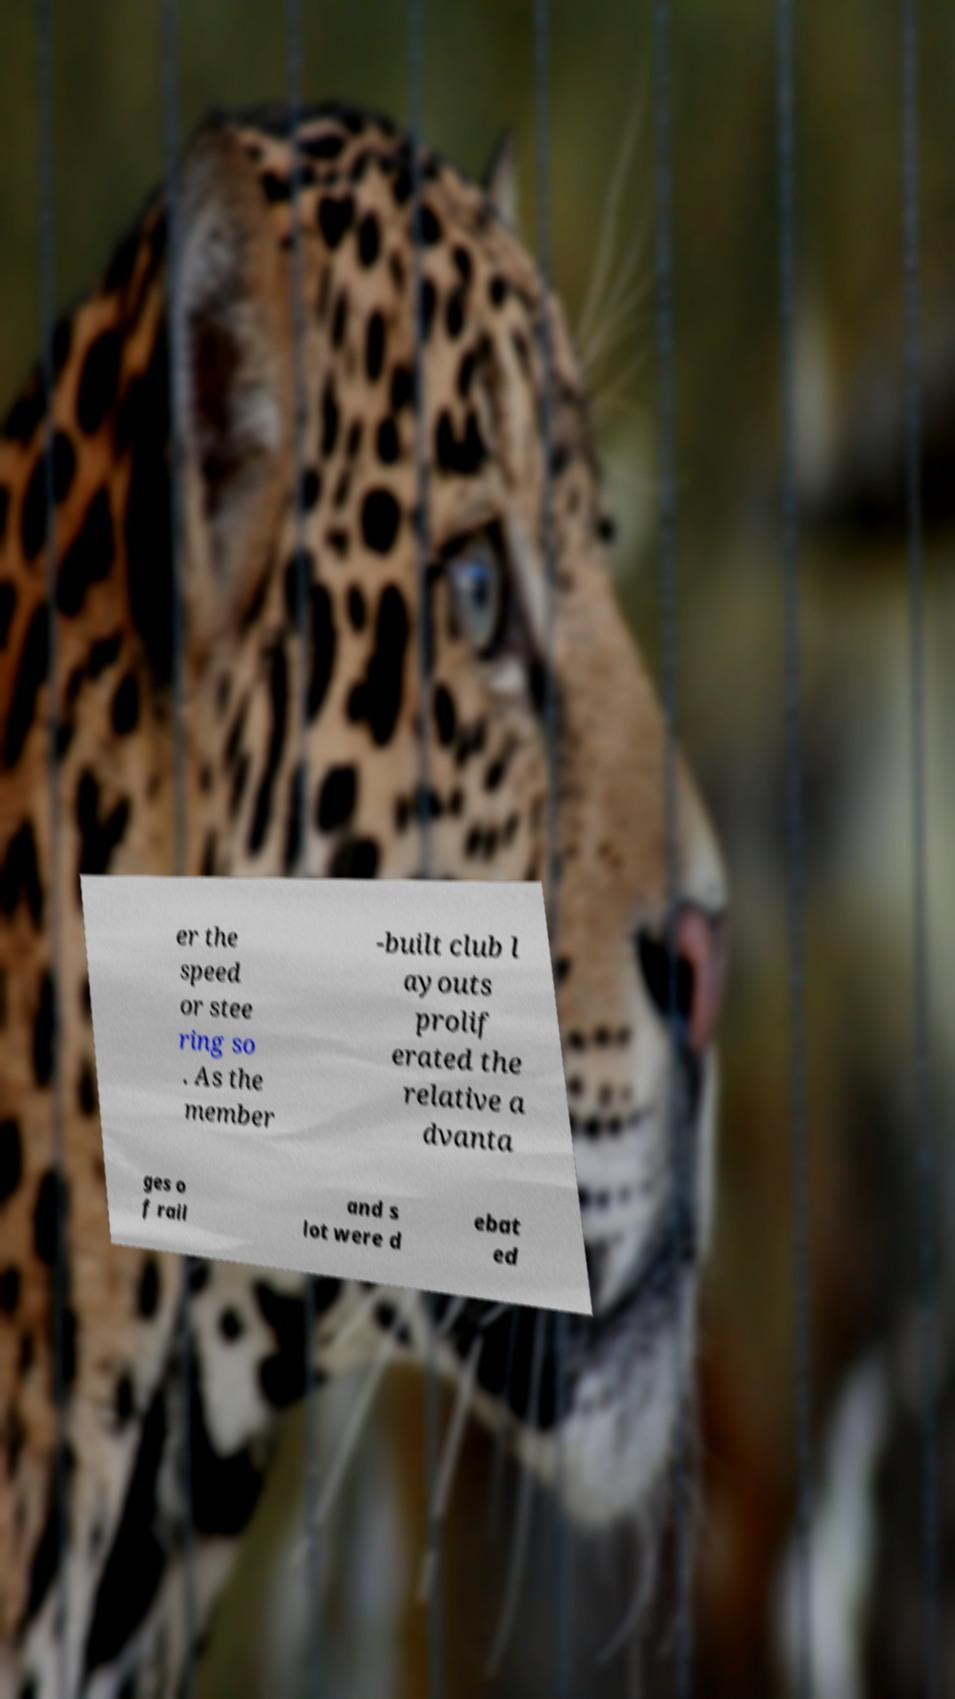Please identify and transcribe the text found in this image. er the speed or stee ring so . As the member -built club l ayouts prolif erated the relative a dvanta ges o f rail and s lot were d ebat ed 